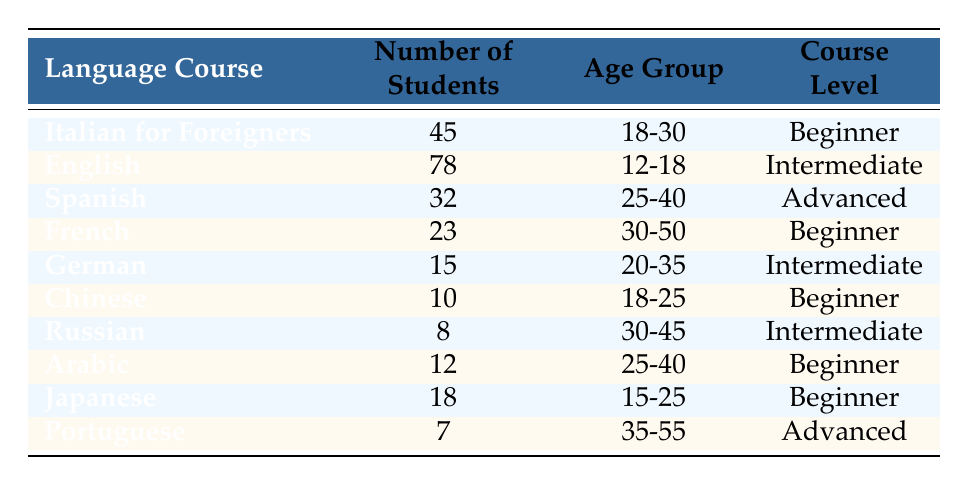What is the enrollment number for the English course? The English course has a listed number of students in the table, which is directly mentioned as 78.
Answer: 78 How many students are enrolled in Beginner level courses? To find the number of students in Beginner level courses, we add the numbers from three courses: Italian for Foreigners (45), French (23), Chinese (10), Arabic (12), and Japanese (18). Adding these gives 45 + 23 + 10 + 12 + 18 = 108.
Answer: 108 Is there a language course with more than 70 students enrolled? Looking at the table, the English course is the only one with 78 students, which is greater than 70. Hence, the answer is yes.
Answer: Yes Which language course has the least number of students? By reviewing the list, the language course with the least enrollment is Portuguese, which has 7 students.
Answer: Portuguese What is the total number of students enrolled in Advanced level courses? The Advanced level courses are Spanish (32) and Portuguese (7). Adding these together gives 32 + 7 = 39.
Answer: 39 Are there more Intermediate courses than Beginner courses? There are three Intermediate courses: English, German, and Russian; and five Beginner courses: Italian for Foreigners, French, Chinese, Arabic, and Japanese. Since 3 is not greater than 5, the answer is no.
Answer: No What is the average number of students in all courses? We sum all student counts: 45 + 78 + 32 + 23 + 15 + 10 + 8 + 12 + 18 + 7 =  308. There are 10 courses, thus the average is 308 / 10 = 30.8.
Answer: 30.8 How many students enrolled are aged between 30-50 years? The courses that cater to the age group 30-50 are Spanish (32), French (23), Russian (8), and Arabic (12). Adding these gives 32 + 23 + 8 + 12 = 75.
Answer: 75 Which language has the highest number of students and at what level is it offered? The English course has the highest number of students at 78, and it is listed as Intermediate level in the table.
Answer: English, Intermediate 